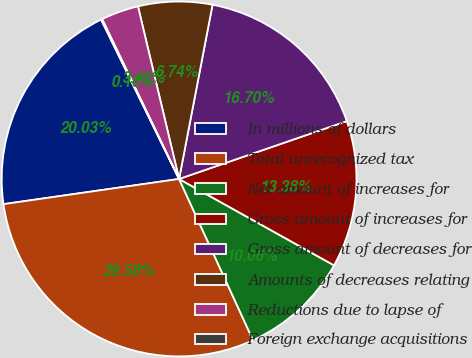<chart> <loc_0><loc_0><loc_500><loc_500><pie_chart><fcel>In millions of dollars<fcel>Total unrecognized tax<fcel>Net amount of increases for<fcel>Gross amount of increases for<fcel>Gross amount of decreases for<fcel>Amounts of decreases relating<fcel>Reductions due to lapse of<fcel>Foreign exchange acquisitions<nl><fcel>20.03%<fcel>29.58%<fcel>10.06%<fcel>13.38%<fcel>16.7%<fcel>6.74%<fcel>3.42%<fcel>0.1%<nl></chart> 